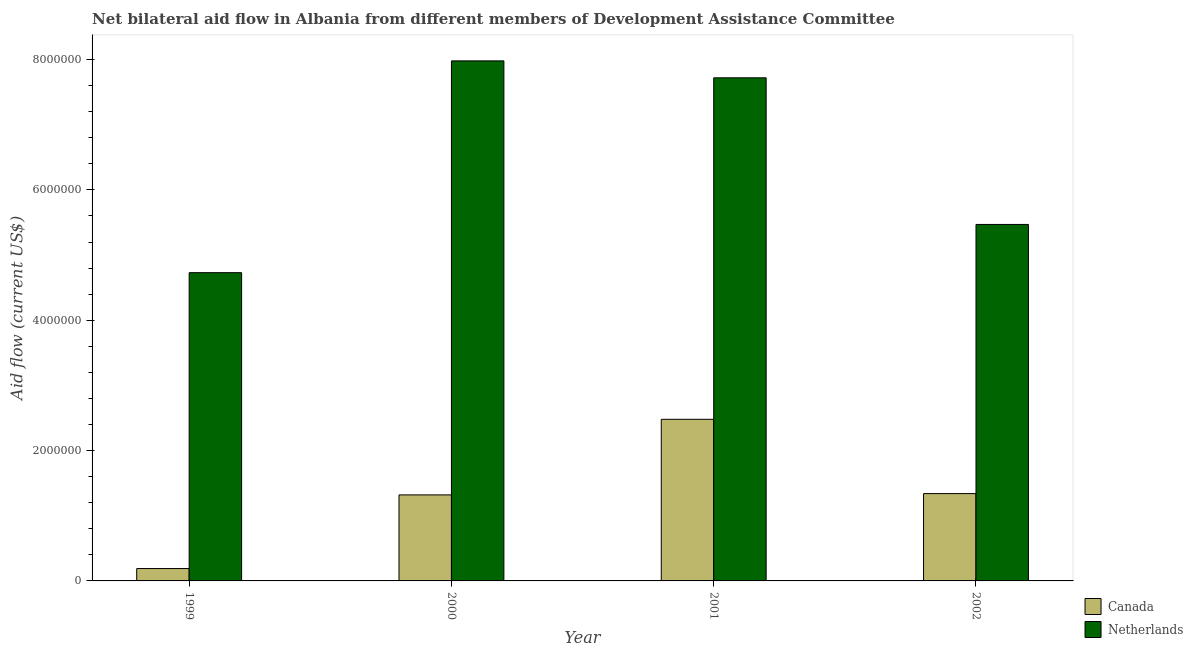How many groups of bars are there?
Your answer should be very brief. 4. How many bars are there on the 3rd tick from the left?
Offer a very short reply. 2. How many bars are there on the 1st tick from the right?
Keep it short and to the point. 2. What is the label of the 2nd group of bars from the left?
Provide a short and direct response. 2000. In how many cases, is the number of bars for a given year not equal to the number of legend labels?
Make the answer very short. 0. What is the amount of aid given by canada in 2002?
Keep it short and to the point. 1.34e+06. Across all years, what is the maximum amount of aid given by netherlands?
Provide a succinct answer. 7.98e+06. Across all years, what is the minimum amount of aid given by netherlands?
Provide a short and direct response. 4.73e+06. In which year was the amount of aid given by netherlands maximum?
Provide a succinct answer. 2000. In which year was the amount of aid given by netherlands minimum?
Provide a short and direct response. 1999. What is the total amount of aid given by netherlands in the graph?
Offer a very short reply. 2.59e+07. What is the difference between the amount of aid given by canada in 1999 and that in 2002?
Your answer should be compact. -1.15e+06. What is the difference between the amount of aid given by netherlands in 1999 and the amount of aid given by canada in 2000?
Provide a short and direct response. -3.25e+06. What is the average amount of aid given by netherlands per year?
Provide a succinct answer. 6.48e+06. What is the ratio of the amount of aid given by netherlands in 1999 to that in 2000?
Offer a very short reply. 0.59. Is the amount of aid given by canada in 2000 less than that in 2002?
Offer a terse response. Yes. Is the difference between the amount of aid given by netherlands in 1999 and 2002 greater than the difference between the amount of aid given by canada in 1999 and 2002?
Your answer should be very brief. No. What is the difference between the highest and the second highest amount of aid given by canada?
Provide a short and direct response. 1.14e+06. What is the difference between the highest and the lowest amount of aid given by netherlands?
Offer a very short reply. 3.25e+06. What does the 2nd bar from the left in 1999 represents?
Your response must be concise. Netherlands. What does the 1st bar from the right in 2001 represents?
Ensure brevity in your answer.  Netherlands. How many bars are there?
Provide a succinct answer. 8. How many years are there in the graph?
Keep it short and to the point. 4. Are the values on the major ticks of Y-axis written in scientific E-notation?
Your answer should be very brief. No. Does the graph contain any zero values?
Keep it short and to the point. No. Where does the legend appear in the graph?
Keep it short and to the point. Bottom right. How many legend labels are there?
Your response must be concise. 2. How are the legend labels stacked?
Make the answer very short. Vertical. What is the title of the graph?
Provide a short and direct response. Net bilateral aid flow in Albania from different members of Development Assistance Committee. What is the label or title of the Y-axis?
Your answer should be compact. Aid flow (current US$). What is the Aid flow (current US$) of Canada in 1999?
Provide a short and direct response. 1.90e+05. What is the Aid flow (current US$) in Netherlands in 1999?
Ensure brevity in your answer.  4.73e+06. What is the Aid flow (current US$) of Canada in 2000?
Ensure brevity in your answer.  1.32e+06. What is the Aid flow (current US$) in Netherlands in 2000?
Keep it short and to the point. 7.98e+06. What is the Aid flow (current US$) of Canada in 2001?
Ensure brevity in your answer.  2.48e+06. What is the Aid flow (current US$) in Netherlands in 2001?
Provide a succinct answer. 7.72e+06. What is the Aid flow (current US$) of Canada in 2002?
Offer a very short reply. 1.34e+06. What is the Aid flow (current US$) of Netherlands in 2002?
Give a very brief answer. 5.47e+06. Across all years, what is the maximum Aid flow (current US$) in Canada?
Your answer should be very brief. 2.48e+06. Across all years, what is the maximum Aid flow (current US$) of Netherlands?
Offer a terse response. 7.98e+06. Across all years, what is the minimum Aid flow (current US$) in Netherlands?
Give a very brief answer. 4.73e+06. What is the total Aid flow (current US$) of Canada in the graph?
Ensure brevity in your answer.  5.33e+06. What is the total Aid flow (current US$) of Netherlands in the graph?
Make the answer very short. 2.59e+07. What is the difference between the Aid flow (current US$) in Canada in 1999 and that in 2000?
Offer a terse response. -1.13e+06. What is the difference between the Aid flow (current US$) in Netherlands in 1999 and that in 2000?
Your response must be concise. -3.25e+06. What is the difference between the Aid flow (current US$) of Canada in 1999 and that in 2001?
Provide a short and direct response. -2.29e+06. What is the difference between the Aid flow (current US$) of Netherlands in 1999 and that in 2001?
Your response must be concise. -2.99e+06. What is the difference between the Aid flow (current US$) in Canada in 1999 and that in 2002?
Your answer should be very brief. -1.15e+06. What is the difference between the Aid flow (current US$) in Netherlands in 1999 and that in 2002?
Ensure brevity in your answer.  -7.40e+05. What is the difference between the Aid flow (current US$) in Canada in 2000 and that in 2001?
Provide a succinct answer. -1.16e+06. What is the difference between the Aid flow (current US$) of Netherlands in 2000 and that in 2002?
Give a very brief answer. 2.51e+06. What is the difference between the Aid flow (current US$) in Canada in 2001 and that in 2002?
Provide a succinct answer. 1.14e+06. What is the difference between the Aid flow (current US$) of Netherlands in 2001 and that in 2002?
Keep it short and to the point. 2.25e+06. What is the difference between the Aid flow (current US$) in Canada in 1999 and the Aid flow (current US$) in Netherlands in 2000?
Offer a terse response. -7.79e+06. What is the difference between the Aid flow (current US$) of Canada in 1999 and the Aid flow (current US$) of Netherlands in 2001?
Make the answer very short. -7.53e+06. What is the difference between the Aid flow (current US$) of Canada in 1999 and the Aid flow (current US$) of Netherlands in 2002?
Offer a very short reply. -5.28e+06. What is the difference between the Aid flow (current US$) of Canada in 2000 and the Aid flow (current US$) of Netherlands in 2001?
Ensure brevity in your answer.  -6.40e+06. What is the difference between the Aid flow (current US$) in Canada in 2000 and the Aid flow (current US$) in Netherlands in 2002?
Ensure brevity in your answer.  -4.15e+06. What is the difference between the Aid flow (current US$) in Canada in 2001 and the Aid flow (current US$) in Netherlands in 2002?
Your answer should be compact. -2.99e+06. What is the average Aid flow (current US$) in Canada per year?
Provide a succinct answer. 1.33e+06. What is the average Aid flow (current US$) in Netherlands per year?
Provide a short and direct response. 6.48e+06. In the year 1999, what is the difference between the Aid flow (current US$) in Canada and Aid flow (current US$) in Netherlands?
Your answer should be compact. -4.54e+06. In the year 2000, what is the difference between the Aid flow (current US$) of Canada and Aid flow (current US$) of Netherlands?
Ensure brevity in your answer.  -6.66e+06. In the year 2001, what is the difference between the Aid flow (current US$) in Canada and Aid flow (current US$) in Netherlands?
Provide a short and direct response. -5.24e+06. In the year 2002, what is the difference between the Aid flow (current US$) of Canada and Aid flow (current US$) of Netherlands?
Your answer should be compact. -4.13e+06. What is the ratio of the Aid flow (current US$) in Canada in 1999 to that in 2000?
Your answer should be very brief. 0.14. What is the ratio of the Aid flow (current US$) in Netherlands in 1999 to that in 2000?
Keep it short and to the point. 0.59. What is the ratio of the Aid flow (current US$) of Canada in 1999 to that in 2001?
Give a very brief answer. 0.08. What is the ratio of the Aid flow (current US$) of Netherlands in 1999 to that in 2001?
Offer a terse response. 0.61. What is the ratio of the Aid flow (current US$) of Canada in 1999 to that in 2002?
Offer a terse response. 0.14. What is the ratio of the Aid flow (current US$) in Netherlands in 1999 to that in 2002?
Provide a short and direct response. 0.86. What is the ratio of the Aid flow (current US$) in Canada in 2000 to that in 2001?
Offer a terse response. 0.53. What is the ratio of the Aid flow (current US$) in Netherlands in 2000 to that in 2001?
Your answer should be compact. 1.03. What is the ratio of the Aid flow (current US$) in Canada in 2000 to that in 2002?
Keep it short and to the point. 0.99. What is the ratio of the Aid flow (current US$) of Netherlands in 2000 to that in 2002?
Give a very brief answer. 1.46. What is the ratio of the Aid flow (current US$) in Canada in 2001 to that in 2002?
Your answer should be compact. 1.85. What is the ratio of the Aid flow (current US$) in Netherlands in 2001 to that in 2002?
Offer a very short reply. 1.41. What is the difference between the highest and the second highest Aid flow (current US$) in Canada?
Ensure brevity in your answer.  1.14e+06. What is the difference between the highest and the second highest Aid flow (current US$) in Netherlands?
Give a very brief answer. 2.60e+05. What is the difference between the highest and the lowest Aid flow (current US$) of Canada?
Give a very brief answer. 2.29e+06. What is the difference between the highest and the lowest Aid flow (current US$) of Netherlands?
Offer a very short reply. 3.25e+06. 